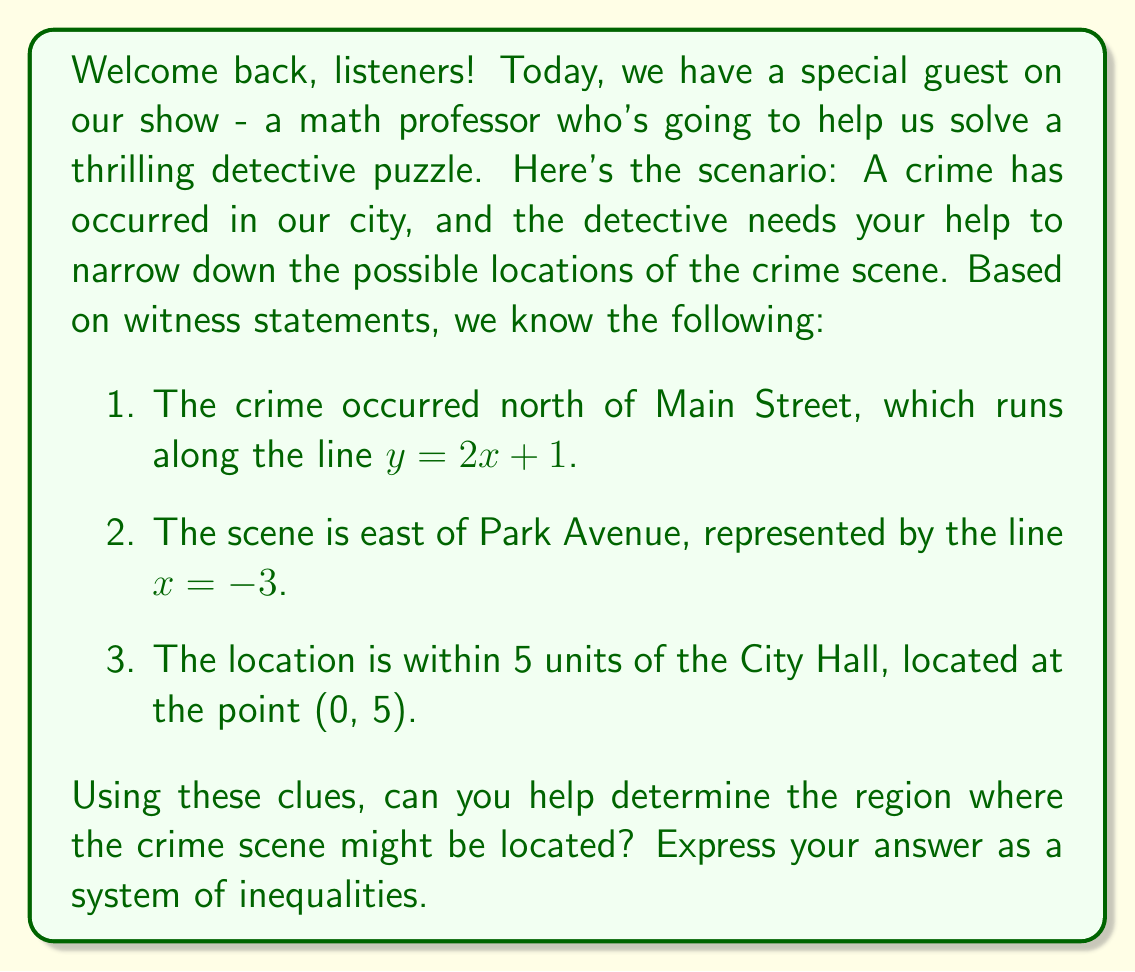Can you solve this math problem? Let's break this down step-by-step:

1. North of Main Street:
   The line $y = 2x + 1$ represents Main Street. To be north of this line, the y-coordinate must be greater than the line equation:
   $$y > 2x + 1$$

2. East of Park Avenue:
   Park Avenue is represented by the line $x = -3$. To be east of this line, the x-coordinate must be greater than -3:
   $$x > -3$$

3. Within 5 units of City Hall:
   City Hall is at (0, 5). To be within 5 units, we use the distance formula:
   $$\sqrt{(x-0)^2 + (y-5)^2} \leq 5$$
   Squaring both sides (since distance is always non-negative):
   $$(x-0)^2 + (y-5)^2 \leq 25$$
   Simplifying:
   $$x^2 + y^2 - 10y + 25 \leq 25$$
   $$x^2 + y^2 - 10y \leq 0$$

Combining these three inequalities gives us the system that defines the possible location of the crime scene.
Answer: The system of inequalities describing the possible location of the crime scene is:

$$\begin{cases}
y > 2x + 1 \\
x > -3 \\
x^2 + y^2 - 10y \leq 0
\end{cases}$$

This system represents the intersection of the area north of Main Street, east of Park Avenue, and within 5 units of City Hall. 